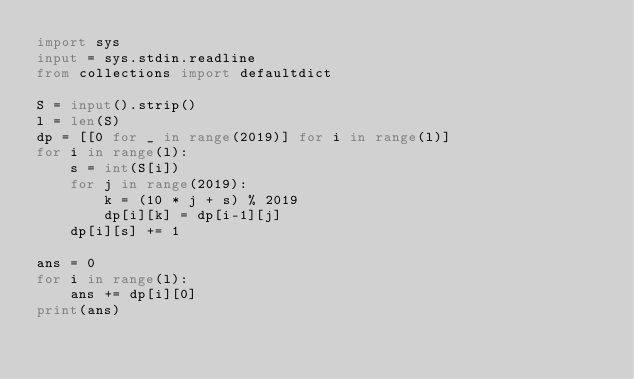<code> <loc_0><loc_0><loc_500><loc_500><_Python_>import sys
input = sys.stdin.readline
from collections import defaultdict

S = input().strip()
l = len(S)
dp = [[0 for _ in range(2019)] for i in range(l)]
for i in range(l):
    s = int(S[i])
    for j in range(2019):
        k = (10 * j + s) % 2019
        dp[i][k] = dp[i-1][j]
    dp[i][s] += 1

ans = 0
for i in range(l):
    ans += dp[i][0]
print(ans)
</code> 